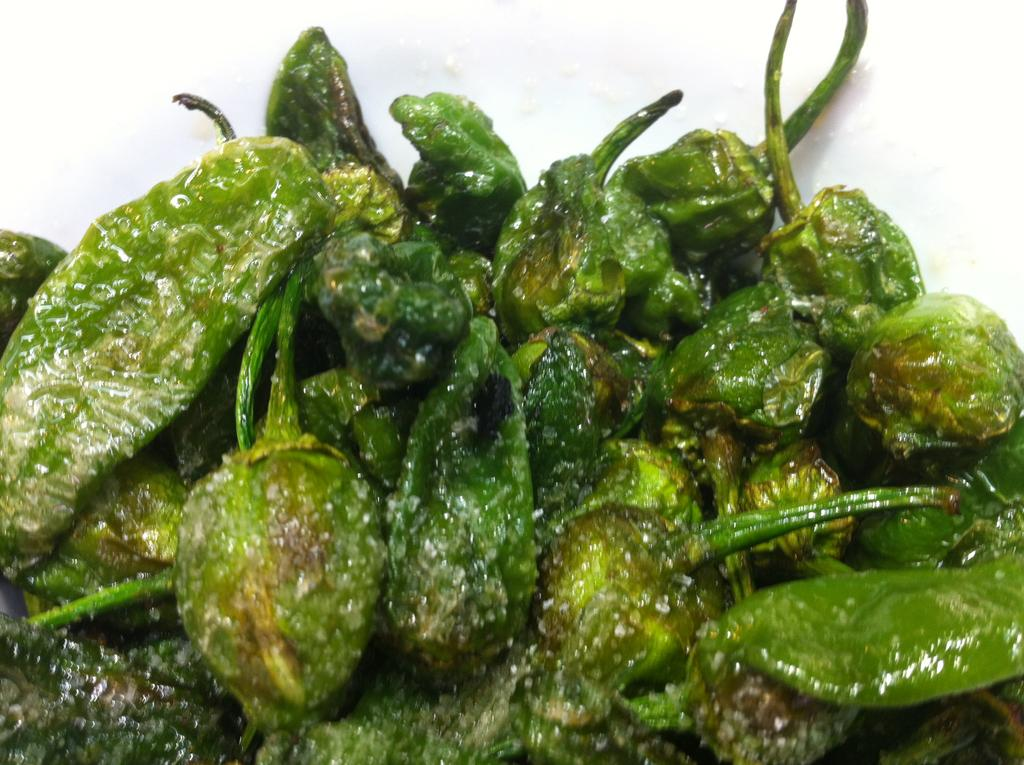What type of food is visible in the image? There are green chilies in the image. What color is the background of the image? The background of the image is white. Can you see a monkey in the image? No, there is no monkey present in the image. What type of light source is used in the image? The provided facts do not mention any light source, so it cannot be determined from the image. 